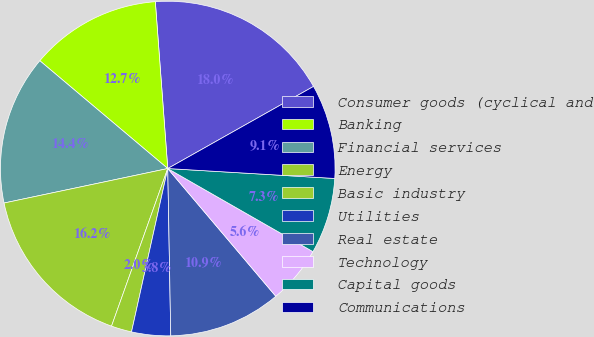Convert chart. <chart><loc_0><loc_0><loc_500><loc_500><pie_chart><fcel>Consumer goods (cyclical and<fcel>Banking<fcel>Financial services<fcel>Energy<fcel>Basic industry<fcel>Utilities<fcel>Real estate<fcel>Technology<fcel>Capital goods<fcel>Communications<nl><fcel>18.02%<fcel>12.67%<fcel>14.45%<fcel>16.24%<fcel>1.98%<fcel>3.76%<fcel>10.89%<fcel>5.55%<fcel>7.33%<fcel>9.11%<nl></chart> 